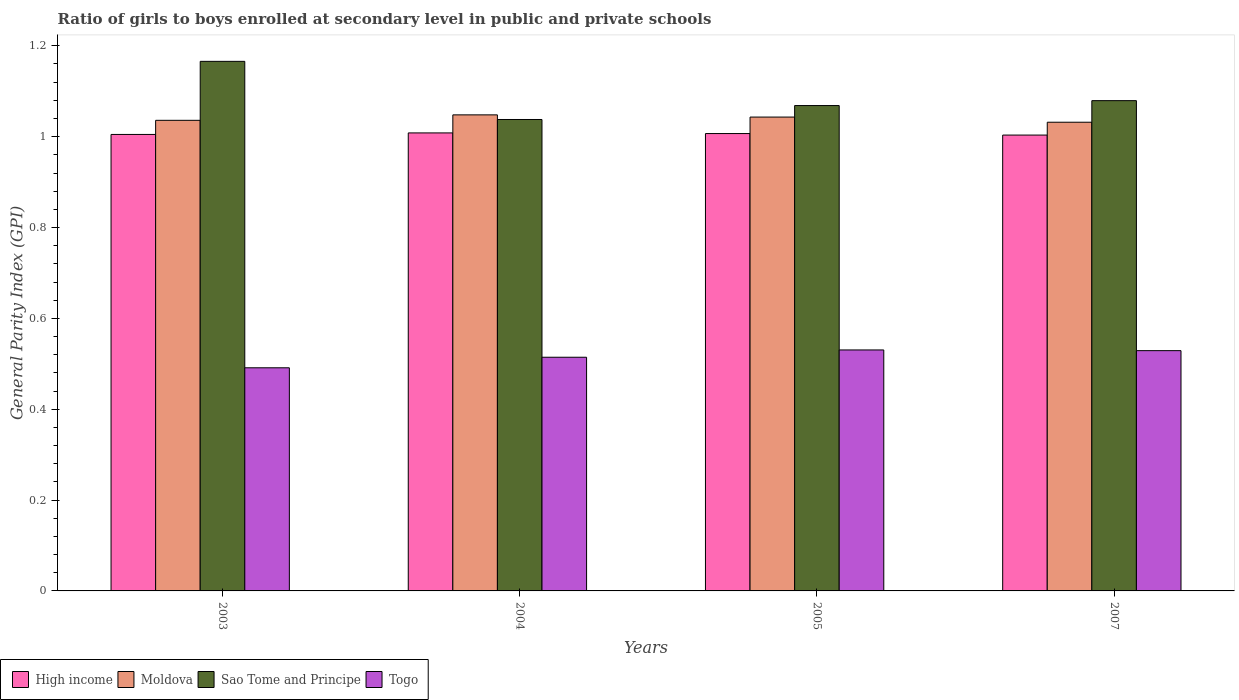Are the number of bars on each tick of the X-axis equal?
Offer a very short reply. Yes. How many bars are there on the 4th tick from the right?
Your answer should be very brief. 4. What is the label of the 3rd group of bars from the left?
Your answer should be very brief. 2005. In how many cases, is the number of bars for a given year not equal to the number of legend labels?
Provide a short and direct response. 0. What is the general parity index in Togo in 2005?
Provide a succinct answer. 0.53. Across all years, what is the maximum general parity index in Sao Tome and Principe?
Provide a succinct answer. 1.17. Across all years, what is the minimum general parity index in Togo?
Your answer should be very brief. 0.49. In which year was the general parity index in High income maximum?
Ensure brevity in your answer.  2004. In which year was the general parity index in Sao Tome and Principe minimum?
Give a very brief answer. 2004. What is the total general parity index in Togo in the graph?
Offer a terse response. 2.07. What is the difference between the general parity index in Togo in 2004 and that in 2007?
Provide a short and direct response. -0.01. What is the difference between the general parity index in Sao Tome and Principe in 2003 and the general parity index in Moldova in 2004?
Your answer should be very brief. 0.12. What is the average general parity index in Sao Tome and Principe per year?
Keep it short and to the point. 1.09. In the year 2007, what is the difference between the general parity index in Togo and general parity index in High income?
Your response must be concise. -0.47. In how many years, is the general parity index in High income greater than 0.28?
Give a very brief answer. 4. What is the ratio of the general parity index in Togo in 2004 to that in 2007?
Provide a short and direct response. 0.97. Is the general parity index in Sao Tome and Principe in 2004 less than that in 2005?
Provide a succinct answer. Yes. Is the difference between the general parity index in Togo in 2003 and 2005 greater than the difference between the general parity index in High income in 2003 and 2005?
Give a very brief answer. No. What is the difference between the highest and the second highest general parity index in High income?
Give a very brief answer. 0. What is the difference between the highest and the lowest general parity index in High income?
Your response must be concise. 0. Is the sum of the general parity index in Moldova in 2003 and 2007 greater than the maximum general parity index in Togo across all years?
Offer a terse response. Yes. Is it the case that in every year, the sum of the general parity index in High income and general parity index in Moldova is greater than the sum of general parity index in Togo and general parity index in Sao Tome and Principe?
Offer a very short reply. Yes. What does the 3rd bar from the left in 2005 represents?
Your answer should be very brief. Sao Tome and Principe. How many bars are there?
Your response must be concise. 16. How many years are there in the graph?
Offer a terse response. 4. What is the difference between two consecutive major ticks on the Y-axis?
Make the answer very short. 0.2. Are the values on the major ticks of Y-axis written in scientific E-notation?
Give a very brief answer. No. Does the graph contain any zero values?
Provide a short and direct response. No. How many legend labels are there?
Your answer should be compact. 4. What is the title of the graph?
Keep it short and to the point. Ratio of girls to boys enrolled at secondary level in public and private schools. Does "New Zealand" appear as one of the legend labels in the graph?
Ensure brevity in your answer.  No. What is the label or title of the X-axis?
Your response must be concise. Years. What is the label or title of the Y-axis?
Provide a succinct answer. General Parity Index (GPI). What is the General Parity Index (GPI) of High income in 2003?
Your answer should be very brief. 1. What is the General Parity Index (GPI) of Moldova in 2003?
Your response must be concise. 1.04. What is the General Parity Index (GPI) in Sao Tome and Principe in 2003?
Give a very brief answer. 1.17. What is the General Parity Index (GPI) in Togo in 2003?
Your answer should be compact. 0.49. What is the General Parity Index (GPI) of High income in 2004?
Give a very brief answer. 1.01. What is the General Parity Index (GPI) of Moldova in 2004?
Make the answer very short. 1.05. What is the General Parity Index (GPI) of Sao Tome and Principe in 2004?
Make the answer very short. 1.04. What is the General Parity Index (GPI) of Togo in 2004?
Give a very brief answer. 0.51. What is the General Parity Index (GPI) of High income in 2005?
Your answer should be very brief. 1.01. What is the General Parity Index (GPI) of Moldova in 2005?
Provide a succinct answer. 1.04. What is the General Parity Index (GPI) in Sao Tome and Principe in 2005?
Your answer should be compact. 1.07. What is the General Parity Index (GPI) in Togo in 2005?
Offer a very short reply. 0.53. What is the General Parity Index (GPI) in High income in 2007?
Ensure brevity in your answer.  1. What is the General Parity Index (GPI) of Moldova in 2007?
Your answer should be compact. 1.03. What is the General Parity Index (GPI) in Sao Tome and Principe in 2007?
Offer a terse response. 1.08. What is the General Parity Index (GPI) of Togo in 2007?
Give a very brief answer. 0.53. Across all years, what is the maximum General Parity Index (GPI) of High income?
Ensure brevity in your answer.  1.01. Across all years, what is the maximum General Parity Index (GPI) of Moldova?
Offer a terse response. 1.05. Across all years, what is the maximum General Parity Index (GPI) in Sao Tome and Principe?
Give a very brief answer. 1.17. Across all years, what is the maximum General Parity Index (GPI) of Togo?
Offer a very short reply. 0.53. Across all years, what is the minimum General Parity Index (GPI) of High income?
Your answer should be very brief. 1. Across all years, what is the minimum General Parity Index (GPI) in Moldova?
Your answer should be compact. 1.03. Across all years, what is the minimum General Parity Index (GPI) of Sao Tome and Principe?
Keep it short and to the point. 1.04. Across all years, what is the minimum General Parity Index (GPI) in Togo?
Provide a short and direct response. 0.49. What is the total General Parity Index (GPI) of High income in the graph?
Offer a terse response. 4.02. What is the total General Parity Index (GPI) of Moldova in the graph?
Give a very brief answer. 4.16. What is the total General Parity Index (GPI) of Sao Tome and Principe in the graph?
Provide a short and direct response. 4.35. What is the total General Parity Index (GPI) of Togo in the graph?
Your response must be concise. 2.07. What is the difference between the General Parity Index (GPI) of High income in 2003 and that in 2004?
Ensure brevity in your answer.  -0. What is the difference between the General Parity Index (GPI) of Moldova in 2003 and that in 2004?
Provide a succinct answer. -0.01. What is the difference between the General Parity Index (GPI) in Sao Tome and Principe in 2003 and that in 2004?
Keep it short and to the point. 0.13. What is the difference between the General Parity Index (GPI) of Togo in 2003 and that in 2004?
Your answer should be compact. -0.02. What is the difference between the General Parity Index (GPI) of High income in 2003 and that in 2005?
Ensure brevity in your answer.  -0. What is the difference between the General Parity Index (GPI) in Moldova in 2003 and that in 2005?
Give a very brief answer. -0.01. What is the difference between the General Parity Index (GPI) in Sao Tome and Principe in 2003 and that in 2005?
Make the answer very short. 0.1. What is the difference between the General Parity Index (GPI) in Togo in 2003 and that in 2005?
Your answer should be very brief. -0.04. What is the difference between the General Parity Index (GPI) of High income in 2003 and that in 2007?
Provide a succinct answer. 0. What is the difference between the General Parity Index (GPI) of Moldova in 2003 and that in 2007?
Provide a succinct answer. 0. What is the difference between the General Parity Index (GPI) in Sao Tome and Principe in 2003 and that in 2007?
Offer a terse response. 0.09. What is the difference between the General Parity Index (GPI) in Togo in 2003 and that in 2007?
Offer a very short reply. -0.04. What is the difference between the General Parity Index (GPI) of High income in 2004 and that in 2005?
Provide a short and direct response. 0. What is the difference between the General Parity Index (GPI) of Moldova in 2004 and that in 2005?
Give a very brief answer. 0. What is the difference between the General Parity Index (GPI) of Sao Tome and Principe in 2004 and that in 2005?
Your answer should be compact. -0.03. What is the difference between the General Parity Index (GPI) in Togo in 2004 and that in 2005?
Keep it short and to the point. -0.02. What is the difference between the General Parity Index (GPI) of High income in 2004 and that in 2007?
Make the answer very short. 0. What is the difference between the General Parity Index (GPI) in Moldova in 2004 and that in 2007?
Provide a succinct answer. 0.02. What is the difference between the General Parity Index (GPI) in Sao Tome and Principe in 2004 and that in 2007?
Provide a succinct answer. -0.04. What is the difference between the General Parity Index (GPI) of Togo in 2004 and that in 2007?
Your response must be concise. -0.01. What is the difference between the General Parity Index (GPI) of High income in 2005 and that in 2007?
Offer a very short reply. 0. What is the difference between the General Parity Index (GPI) of Moldova in 2005 and that in 2007?
Give a very brief answer. 0.01. What is the difference between the General Parity Index (GPI) of Sao Tome and Principe in 2005 and that in 2007?
Provide a succinct answer. -0.01. What is the difference between the General Parity Index (GPI) in Togo in 2005 and that in 2007?
Your answer should be very brief. 0. What is the difference between the General Parity Index (GPI) of High income in 2003 and the General Parity Index (GPI) of Moldova in 2004?
Provide a short and direct response. -0.04. What is the difference between the General Parity Index (GPI) in High income in 2003 and the General Parity Index (GPI) in Sao Tome and Principe in 2004?
Provide a succinct answer. -0.03. What is the difference between the General Parity Index (GPI) of High income in 2003 and the General Parity Index (GPI) of Togo in 2004?
Your answer should be very brief. 0.49. What is the difference between the General Parity Index (GPI) in Moldova in 2003 and the General Parity Index (GPI) in Sao Tome and Principe in 2004?
Offer a terse response. -0. What is the difference between the General Parity Index (GPI) of Moldova in 2003 and the General Parity Index (GPI) of Togo in 2004?
Your answer should be compact. 0.52. What is the difference between the General Parity Index (GPI) of Sao Tome and Principe in 2003 and the General Parity Index (GPI) of Togo in 2004?
Ensure brevity in your answer.  0.65. What is the difference between the General Parity Index (GPI) in High income in 2003 and the General Parity Index (GPI) in Moldova in 2005?
Ensure brevity in your answer.  -0.04. What is the difference between the General Parity Index (GPI) in High income in 2003 and the General Parity Index (GPI) in Sao Tome and Principe in 2005?
Your response must be concise. -0.06. What is the difference between the General Parity Index (GPI) of High income in 2003 and the General Parity Index (GPI) of Togo in 2005?
Provide a short and direct response. 0.47. What is the difference between the General Parity Index (GPI) in Moldova in 2003 and the General Parity Index (GPI) in Sao Tome and Principe in 2005?
Ensure brevity in your answer.  -0.03. What is the difference between the General Parity Index (GPI) of Moldova in 2003 and the General Parity Index (GPI) of Togo in 2005?
Keep it short and to the point. 0.51. What is the difference between the General Parity Index (GPI) in Sao Tome and Principe in 2003 and the General Parity Index (GPI) in Togo in 2005?
Keep it short and to the point. 0.64. What is the difference between the General Parity Index (GPI) of High income in 2003 and the General Parity Index (GPI) of Moldova in 2007?
Keep it short and to the point. -0.03. What is the difference between the General Parity Index (GPI) of High income in 2003 and the General Parity Index (GPI) of Sao Tome and Principe in 2007?
Your answer should be very brief. -0.07. What is the difference between the General Parity Index (GPI) of High income in 2003 and the General Parity Index (GPI) of Togo in 2007?
Your answer should be very brief. 0.48. What is the difference between the General Parity Index (GPI) in Moldova in 2003 and the General Parity Index (GPI) in Sao Tome and Principe in 2007?
Your answer should be very brief. -0.04. What is the difference between the General Parity Index (GPI) in Moldova in 2003 and the General Parity Index (GPI) in Togo in 2007?
Offer a terse response. 0.51. What is the difference between the General Parity Index (GPI) in Sao Tome and Principe in 2003 and the General Parity Index (GPI) in Togo in 2007?
Provide a short and direct response. 0.64. What is the difference between the General Parity Index (GPI) in High income in 2004 and the General Parity Index (GPI) in Moldova in 2005?
Provide a succinct answer. -0.03. What is the difference between the General Parity Index (GPI) of High income in 2004 and the General Parity Index (GPI) of Sao Tome and Principe in 2005?
Provide a succinct answer. -0.06. What is the difference between the General Parity Index (GPI) of High income in 2004 and the General Parity Index (GPI) of Togo in 2005?
Provide a succinct answer. 0.48. What is the difference between the General Parity Index (GPI) in Moldova in 2004 and the General Parity Index (GPI) in Sao Tome and Principe in 2005?
Keep it short and to the point. -0.02. What is the difference between the General Parity Index (GPI) in Moldova in 2004 and the General Parity Index (GPI) in Togo in 2005?
Provide a succinct answer. 0.52. What is the difference between the General Parity Index (GPI) of Sao Tome and Principe in 2004 and the General Parity Index (GPI) of Togo in 2005?
Offer a terse response. 0.51. What is the difference between the General Parity Index (GPI) in High income in 2004 and the General Parity Index (GPI) in Moldova in 2007?
Keep it short and to the point. -0.02. What is the difference between the General Parity Index (GPI) of High income in 2004 and the General Parity Index (GPI) of Sao Tome and Principe in 2007?
Your answer should be compact. -0.07. What is the difference between the General Parity Index (GPI) of High income in 2004 and the General Parity Index (GPI) of Togo in 2007?
Ensure brevity in your answer.  0.48. What is the difference between the General Parity Index (GPI) in Moldova in 2004 and the General Parity Index (GPI) in Sao Tome and Principe in 2007?
Make the answer very short. -0.03. What is the difference between the General Parity Index (GPI) of Moldova in 2004 and the General Parity Index (GPI) of Togo in 2007?
Your answer should be compact. 0.52. What is the difference between the General Parity Index (GPI) in Sao Tome and Principe in 2004 and the General Parity Index (GPI) in Togo in 2007?
Your response must be concise. 0.51. What is the difference between the General Parity Index (GPI) in High income in 2005 and the General Parity Index (GPI) in Moldova in 2007?
Offer a terse response. -0.03. What is the difference between the General Parity Index (GPI) in High income in 2005 and the General Parity Index (GPI) in Sao Tome and Principe in 2007?
Your answer should be very brief. -0.07. What is the difference between the General Parity Index (GPI) of High income in 2005 and the General Parity Index (GPI) of Togo in 2007?
Your response must be concise. 0.48. What is the difference between the General Parity Index (GPI) of Moldova in 2005 and the General Parity Index (GPI) of Sao Tome and Principe in 2007?
Provide a succinct answer. -0.04. What is the difference between the General Parity Index (GPI) in Moldova in 2005 and the General Parity Index (GPI) in Togo in 2007?
Keep it short and to the point. 0.51. What is the difference between the General Parity Index (GPI) in Sao Tome and Principe in 2005 and the General Parity Index (GPI) in Togo in 2007?
Provide a succinct answer. 0.54. What is the average General Parity Index (GPI) of High income per year?
Give a very brief answer. 1.01. What is the average General Parity Index (GPI) in Moldova per year?
Offer a terse response. 1.04. What is the average General Parity Index (GPI) in Sao Tome and Principe per year?
Provide a short and direct response. 1.09. What is the average General Parity Index (GPI) in Togo per year?
Your answer should be compact. 0.52. In the year 2003, what is the difference between the General Parity Index (GPI) of High income and General Parity Index (GPI) of Moldova?
Provide a short and direct response. -0.03. In the year 2003, what is the difference between the General Parity Index (GPI) of High income and General Parity Index (GPI) of Sao Tome and Principe?
Offer a very short reply. -0.16. In the year 2003, what is the difference between the General Parity Index (GPI) in High income and General Parity Index (GPI) in Togo?
Provide a short and direct response. 0.51. In the year 2003, what is the difference between the General Parity Index (GPI) of Moldova and General Parity Index (GPI) of Sao Tome and Principe?
Your response must be concise. -0.13. In the year 2003, what is the difference between the General Parity Index (GPI) in Moldova and General Parity Index (GPI) in Togo?
Offer a terse response. 0.54. In the year 2003, what is the difference between the General Parity Index (GPI) in Sao Tome and Principe and General Parity Index (GPI) in Togo?
Keep it short and to the point. 0.67. In the year 2004, what is the difference between the General Parity Index (GPI) of High income and General Parity Index (GPI) of Moldova?
Offer a very short reply. -0.04. In the year 2004, what is the difference between the General Parity Index (GPI) in High income and General Parity Index (GPI) in Sao Tome and Principe?
Provide a short and direct response. -0.03. In the year 2004, what is the difference between the General Parity Index (GPI) of High income and General Parity Index (GPI) of Togo?
Keep it short and to the point. 0.49. In the year 2004, what is the difference between the General Parity Index (GPI) of Moldova and General Parity Index (GPI) of Sao Tome and Principe?
Your answer should be compact. 0.01. In the year 2004, what is the difference between the General Parity Index (GPI) in Moldova and General Parity Index (GPI) in Togo?
Provide a short and direct response. 0.53. In the year 2004, what is the difference between the General Parity Index (GPI) in Sao Tome and Principe and General Parity Index (GPI) in Togo?
Offer a very short reply. 0.52. In the year 2005, what is the difference between the General Parity Index (GPI) in High income and General Parity Index (GPI) in Moldova?
Ensure brevity in your answer.  -0.04. In the year 2005, what is the difference between the General Parity Index (GPI) in High income and General Parity Index (GPI) in Sao Tome and Principe?
Offer a terse response. -0.06. In the year 2005, what is the difference between the General Parity Index (GPI) in High income and General Parity Index (GPI) in Togo?
Your answer should be very brief. 0.48. In the year 2005, what is the difference between the General Parity Index (GPI) of Moldova and General Parity Index (GPI) of Sao Tome and Principe?
Your answer should be compact. -0.03. In the year 2005, what is the difference between the General Parity Index (GPI) in Moldova and General Parity Index (GPI) in Togo?
Provide a succinct answer. 0.51. In the year 2005, what is the difference between the General Parity Index (GPI) in Sao Tome and Principe and General Parity Index (GPI) in Togo?
Keep it short and to the point. 0.54. In the year 2007, what is the difference between the General Parity Index (GPI) in High income and General Parity Index (GPI) in Moldova?
Give a very brief answer. -0.03. In the year 2007, what is the difference between the General Parity Index (GPI) in High income and General Parity Index (GPI) in Sao Tome and Principe?
Provide a short and direct response. -0.08. In the year 2007, what is the difference between the General Parity Index (GPI) in High income and General Parity Index (GPI) in Togo?
Provide a succinct answer. 0.47. In the year 2007, what is the difference between the General Parity Index (GPI) of Moldova and General Parity Index (GPI) of Sao Tome and Principe?
Your answer should be compact. -0.05. In the year 2007, what is the difference between the General Parity Index (GPI) of Moldova and General Parity Index (GPI) of Togo?
Provide a short and direct response. 0.5. In the year 2007, what is the difference between the General Parity Index (GPI) of Sao Tome and Principe and General Parity Index (GPI) of Togo?
Provide a short and direct response. 0.55. What is the ratio of the General Parity Index (GPI) of High income in 2003 to that in 2004?
Provide a succinct answer. 1. What is the ratio of the General Parity Index (GPI) of Sao Tome and Principe in 2003 to that in 2004?
Make the answer very short. 1.12. What is the ratio of the General Parity Index (GPI) of Togo in 2003 to that in 2004?
Your answer should be very brief. 0.95. What is the ratio of the General Parity Index (GPI) in High income in 2003 to that in 2005?
Make the answer very short. 1. What is the ratio of the General Parity Index (GPI) in Sao Tome and Principe in 2003 to that in 2005?
Offer a very short reply. 1.09. What is the ratio of the General Parity Index (GPI) in Togo in 2003 to that in 2005?
Give a very brief answer. 0.93. What is the ratio of the General Parity Index (GPI) in Sao Tome and Principe in 2003 to that in 2007?
Keep it short and to the point. 1.08. What is the ratio of the General Parity Index (GPI) of Togo in 2003 to that in 2007?
Ensure brevity in your answer.  0.93. What is the ratio of the General Parity Index (GPI) of Moldova in 2004 to that in 2005?
Offer a very short reply. 1. What is the ratio of the General Parity Index (GPI) in Sao Tome and Principe in 2004 to that in 2005?
Ensure brevity in your answer.  0.97. What is the ratio of the General Parity Index (GPI) in Togo in 2004 to that in 2005?
Your answer should be compact. 0.97. What is the ratio of the General Parity Index (GPI) of Moldova in 2004 to that in 2007?
Make the answer very short. 1.02. What is the ratio of the General Parity Index (GPI) in Sao Tome and Principe in 2004 to that in 2007?
Keep it short and to the point. 0.96. What is the ratio of the General Parity Index (GPI) of Togo in 2004 to that in 2007?
Keep it short and to the point. 0.97. What is the ratio of the General Parity Index (GPI) in High income in 2005 to that in 2007?
Offer a terse response. 1. What is the ratio of the General Parity Index (GPI) in Moldova in 2005 to that in 2007?
Offer a terse response. 1.01. What is the ratio of the General Parity Index (GPI) in Sao Tome and Principe in 2005 to that in 2007?
Your answer should be very brief. 0.99. What is the difference between the highest and the second highest General Parity Index (GPI) of High income?
Keep it short and to the point. 0. What is the difference between the highest and the second highest General Parity Index (GPI) of Moldova?
Give a very brief answer. 0. What is the difference between the highest and the second highest General Parity Index (GPI) in Sao Tome and Principe?
Ensure brevity in your answer.  0.09. What is the difference between the highest and the second highest General Parity Index (GPI) of Togo?
Offer a very short reply. 0. What is the difference between the highest and the lowest General Parity Index (GPI) in High income?
Make the answer very short. 0. What is the difference between the highest and the lowest General Parity Index (GPI) in Moldova?
Provide a succinct answer. 0.02. What is the difference between the highest and the lowest General Parity Index (GPI) of Sao Tome and Principe?
Provide a short and direct response. 0.13. What is the difference between the highest and the lowest General Parity Index (GPI) of Togo?
Keep it short and to the point. 0.04. 